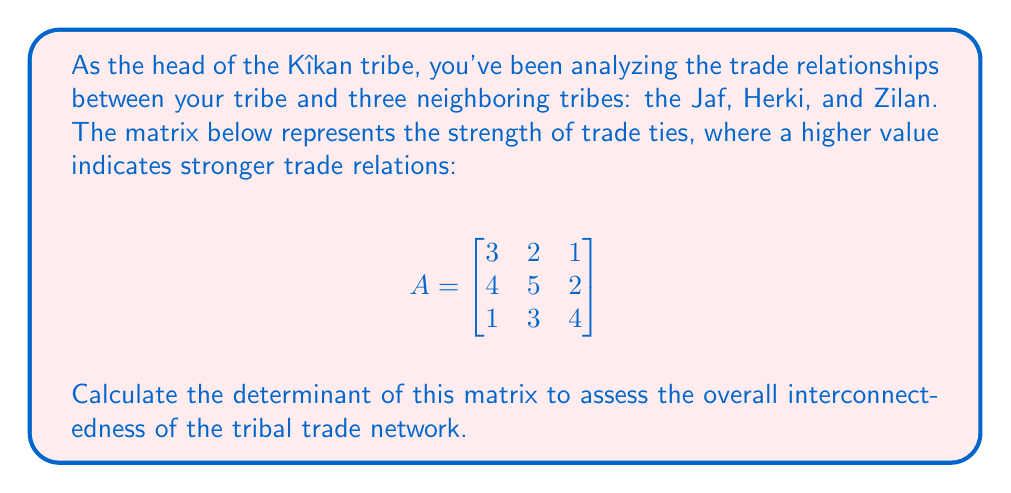Can you solve this math problem? To compute the determinant of the 3x3 matrix A, we'll use the Sarrus' rule:

1) First, write out the formula for the determinant:

   $\det(A) = a_{11}a_{22}a_{33} + a_{12}a_{23}a_{31} + a_{13}a_{21}a_{32} - a_{13}a_{22}a_{31} - a_{11}a_{23}a_{32} - a_{12}a_{21}a_{33}$

2) Substitute the values from the matrix:

   $\det(A) = (3 \cdot 5 \cdot 4) + (2 \cdot 2 \cdot 1) + (1 \cdot 4 \cdot 3) - (1 \cdot 5 \cdot 1) - (3 \cdot 2 \cdot 3) - (2 \cdot 4 \cdot 4)$

3) Multiply the terms:

   $\det(A) = 60 + 4 + 12 - 5 - 18 - 32$

4) Sum up all the terms:

   $\det(A) = 21$

The positive determinant indicates that the trade relationships form a stable and interconnected network among the tribes.
Answer: $21$ 